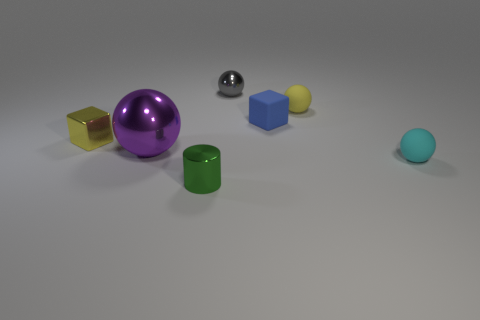Add 3 small gray metal cylinders. How many objects exist? 10 Subtract all spheres. How many objects are left? 3 Add 4 yellow metal cubes. How many yellow metal cubes are left? 5 Add 2 small yellow blocks. How many small yellow blocks exist? 3 Subtract 0 purple cubes. How many objects are left? 7 Subtract all tiny blue objects. Subtract all small yellow metallic objects. How many objects are left? 5 